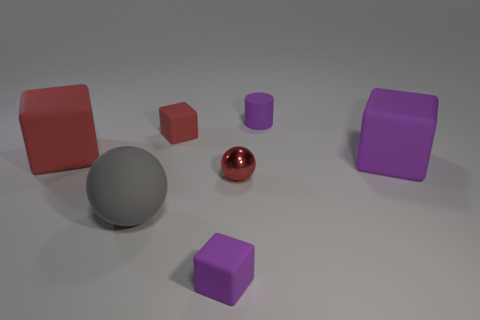Subtract all large red blocks. How many blocks are left? 3 Subtract all gray balls. How many balls are left? 1 Subtract 1 spheres. How many spheres are left? 1 Add 2 red spheres. How many objects exist? 9 Subtract all purple balls. How many purple blocks are left? 2 Subtract all cylinders. How many objects are left? 6 Subtract all brown blocks. Subtract all brown balls. How many blocks are left? 4 Subtract all large green rubber spheres. Subtract all blocks. How many objects are left? 3 Add 6 large purple matte cubes. How many large purple matte cubes are left? 7 Add 2 green matte cylinders. How many green matte cylinders exist? 2 